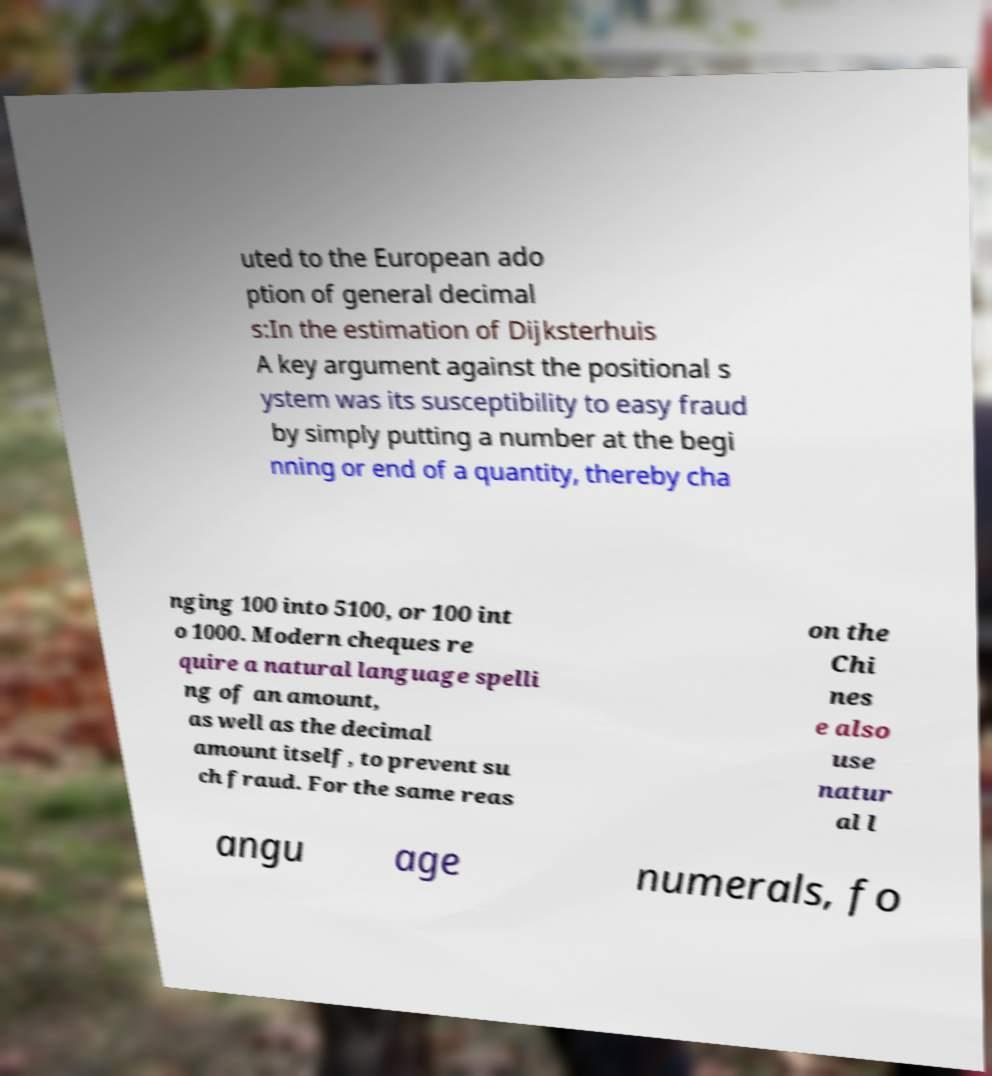There's text embedded in this image that I need extracted. Can you transcribe it verbatim? uted to the European ado ption of general decimal s:In the estimation of Dijksterhuis A key argument against the positional s ystem was its susceptibility to easy fraud by simply putting a number at the begi nning or end of a quantity, thereby cha nging 100 into 5100, or 100 int o 1000. Modern cheques re quire a natural language spelli ng of an amount, as well as the decimal amount itself, to prevent su ch fraud. For the same reas on the Chi nes e also use natur al l angu age numerals, fo 